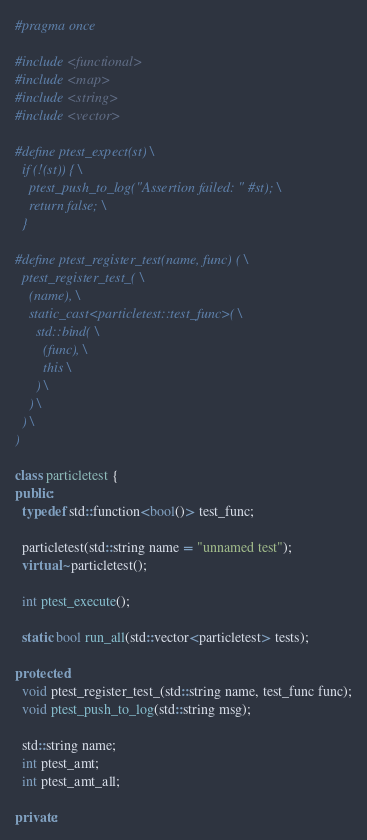Convert code to text. <code><loc_0><loc_0><loc_500><loc_500><_C++_>#pragma once

#include <functional>
#include <map>
#include <string>
#include <vector>

#define ptest_expect(st) \
  if (!(st)) { \
    ptest_push_to_log("Assertion failed: " #st); \
    return false; \
  }

#define ptest_register_test(name, func) ( \
  ptest_register_test_( \
    (name), \
    static_cast<particletest::test_func>( \
      std::bind( \
        (func), \
        this \
      ) \
    ) \
  ) \
)

class particletest {
public:
  typedef std::function<bool()> test_func;

  particletest(std::string name = "unnamed test");
  virtual ~particletest();

  int ptest_execute();

  static bool run_all(std::vector<particletest> tests);

protected:
  void ptest_register_test_(std::string name, test_func func);
  void ptest_push_to_log(std::string msg);

  std::string name;
  int ptest_amt;
  int ptest_amt_all;

private:</code> 